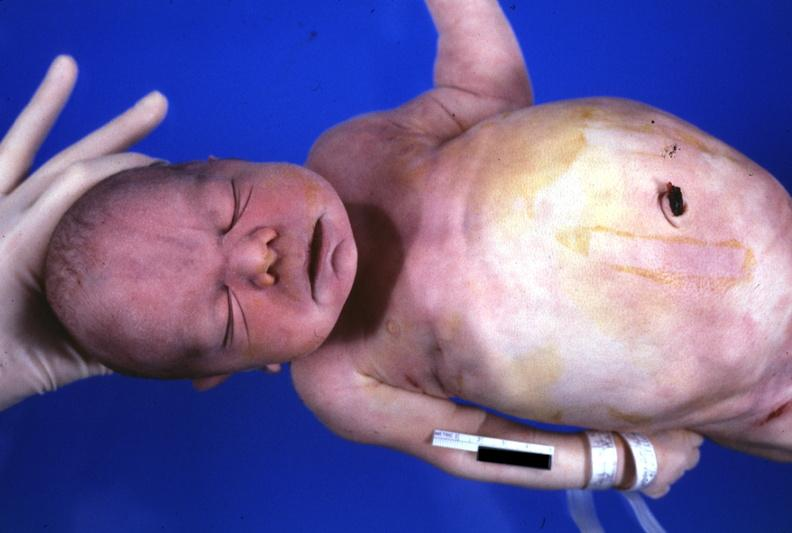what is present?
Answer the question using a single word or phrase. Face 